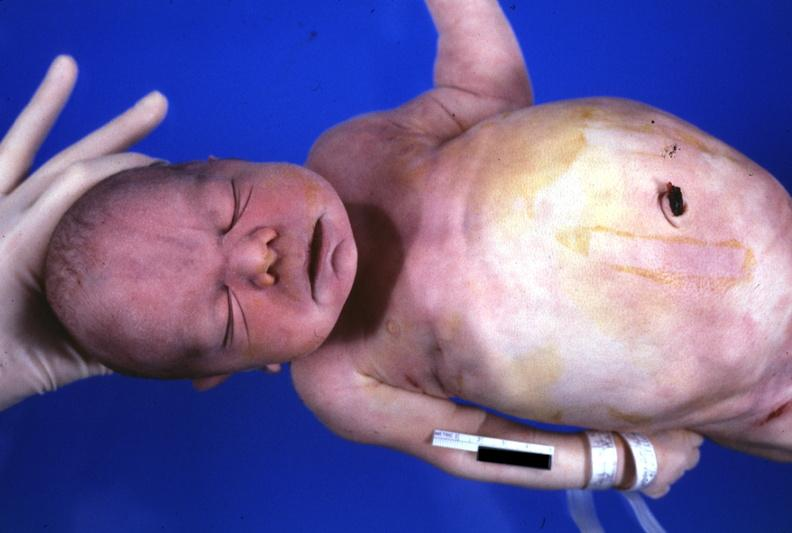what is present?
Answer the question using a single word or phrase. Face 